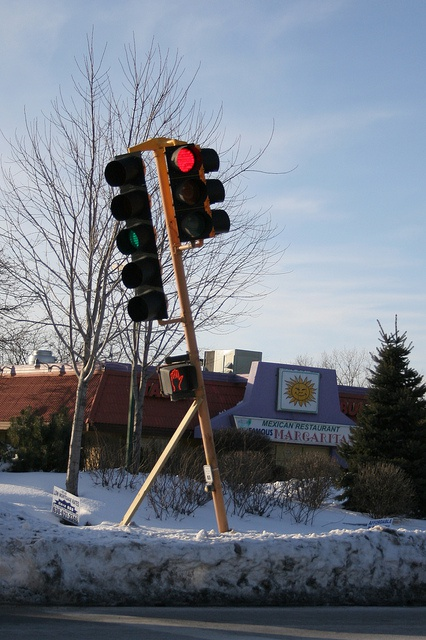Describe the objects in this image and their specific colors. I can see traffic light in darkgray, black, gray, and lightgray tones, traffic light in darkgray, black, maroon, red, and gray tones, and traffic light in darkgray, black, brown, and maroon tones in this image. 